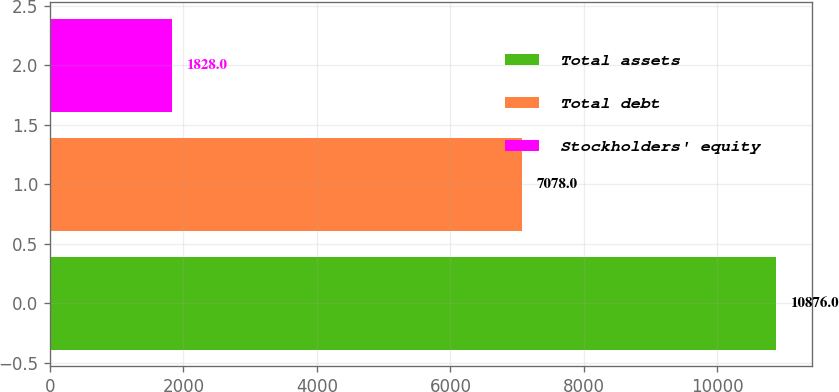<chart> <loc_0><loc_0><loc_500><loc_500><bar_chart><fcel>Total assets<fcel>Total debt<fcel>Stockholders' equity<nl><fcel>10876<fcel>7078<fcel>1828<nl></chart> 